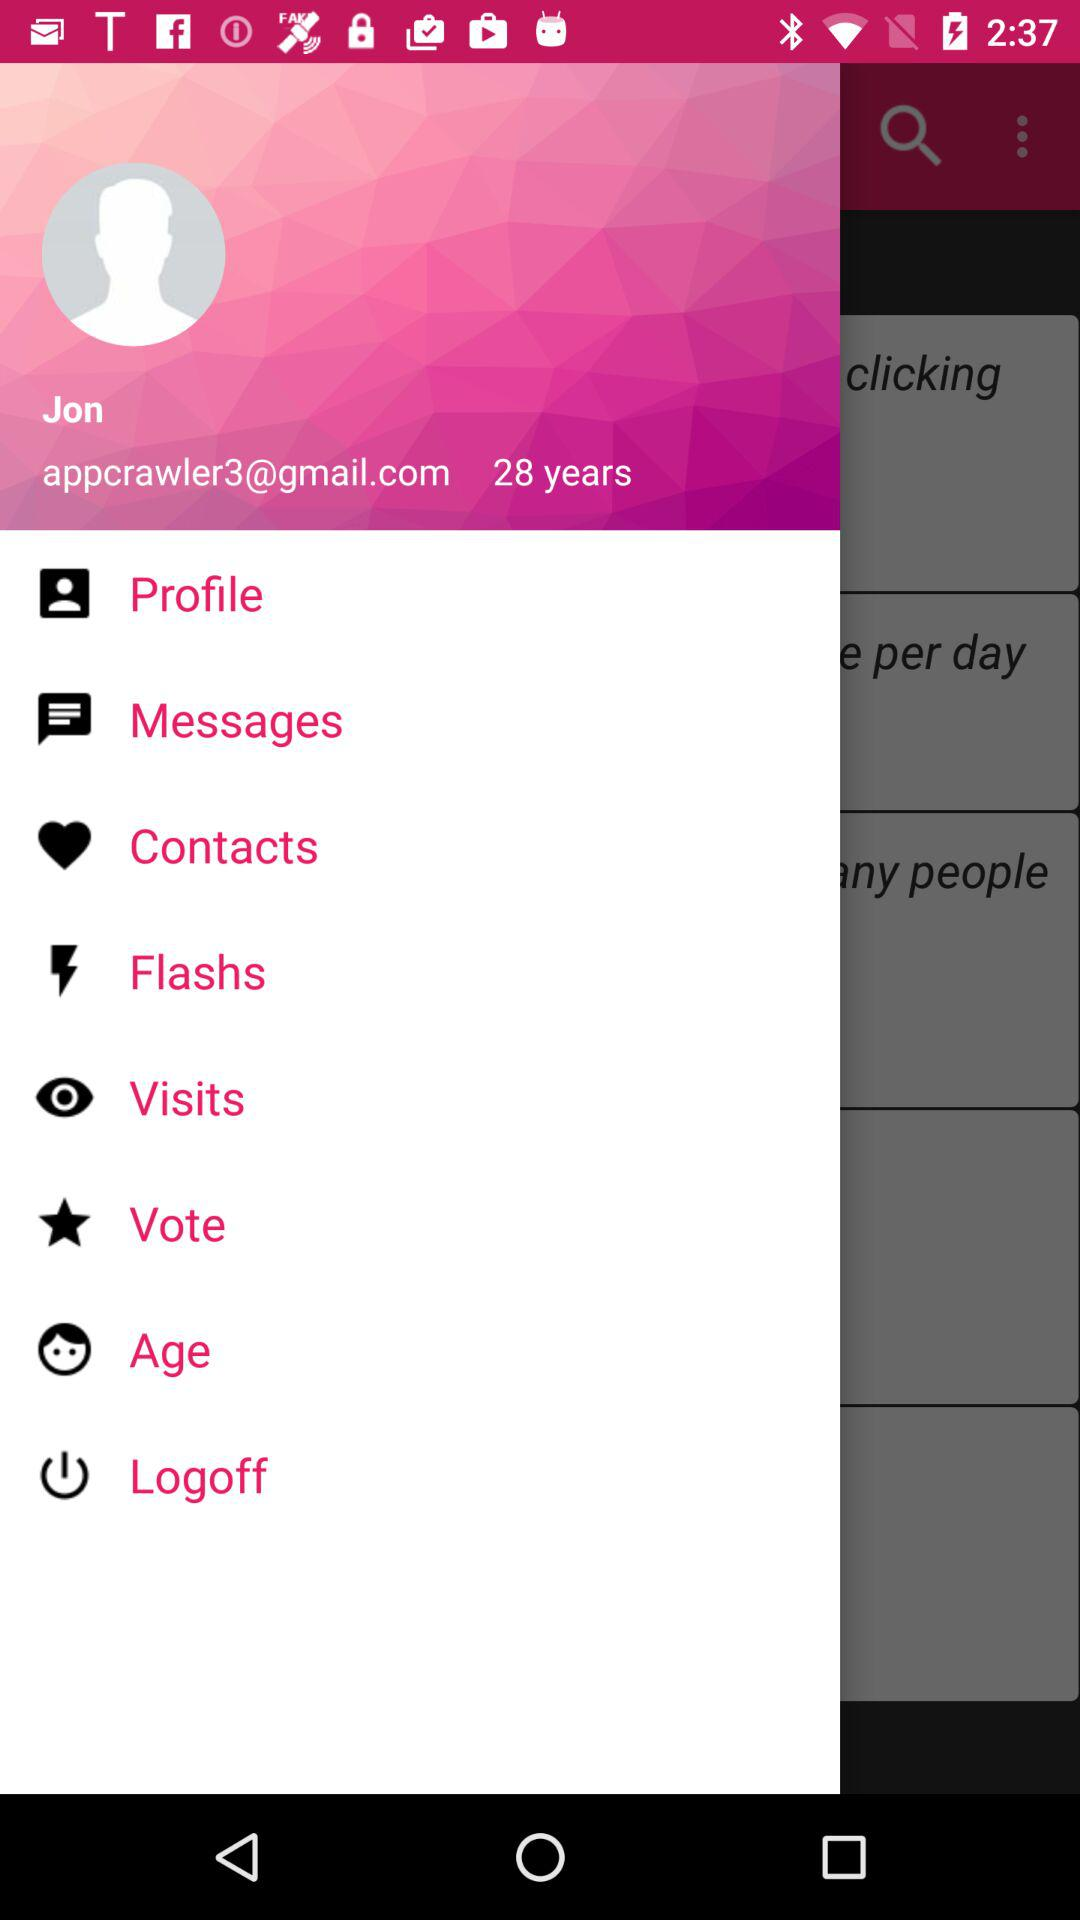What is the user name? The user name is Jon. 